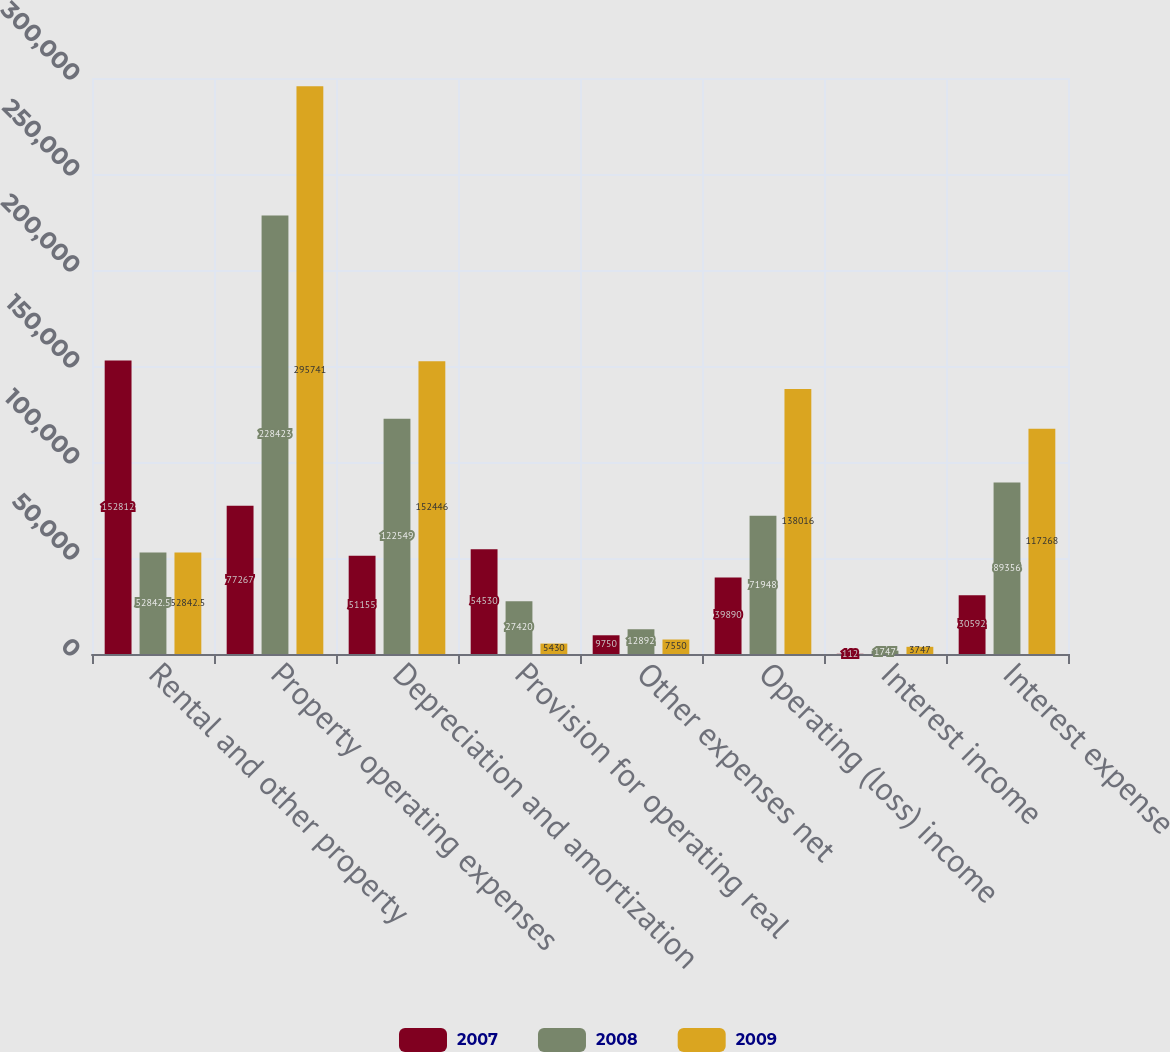Convert chart. <chart><loc_0><loc_0><loc_500><loc_500><stacked_bar_chart><ecel><fcel>Rental and other property<fcel>Property operating expenses<fcel>Depreciation and amortization<fcel>Provision for operating real<fcel>Other expenses net<fcel>Operating (loss) income<fcel>Interest income<fcel>Interest expense<nl><fcel>2007<fcel>152812<fcel>77267<fcel>51155<fcel>54530<fcel>9750<fcel>39890<fcel>112<fcel>30592<nl><fcel>2008<fcel>52842.5<fcel>228423<fcel>122549<fcel>27420<fcel>12892<fcel>71948<fcel>1747<fcel>89356<nl><fcel>2009<fcel>52842.5<fcel>295741<fcel>152446<fcel>5430<fcel>7550<fcel>138016<fcel>3747<fcel>117268<nl></chart> 